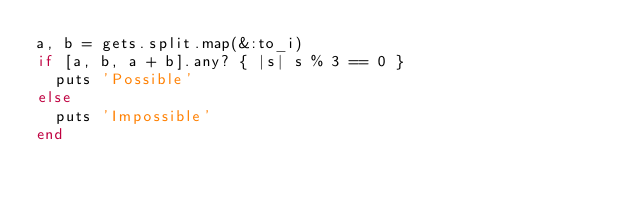<code> <loc_0><loc_0><loc_500><loc_500><_Ruby_>a, b = gets.split.map(&:to_i)
if [a, b, a + b].any? { |s| s % 3 == 0 }
  puts 'Possible'
else
  puts 'Impossible'
end
</code> 